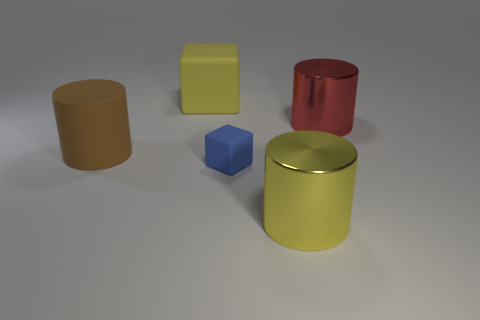Describe the lighting and shadows in the scene, what can you infer from them? The scene is lit from above as indicated by the shadows that fall mostly to the side and slightly behind the objects. The shadows are soft and diffused, suggesting either a single diffuse light source like a cloudy sky or multiple light sources that are softening each other's shadows.  Does the lighting affect the appearance of object colors? Yes, the lighting in a scene can significantly affect the appearance of object colors. In this case, the diffused light provides a true representation of the colors without creating harsh highlights or deep shadows, maintaining the integrity of the colors. 